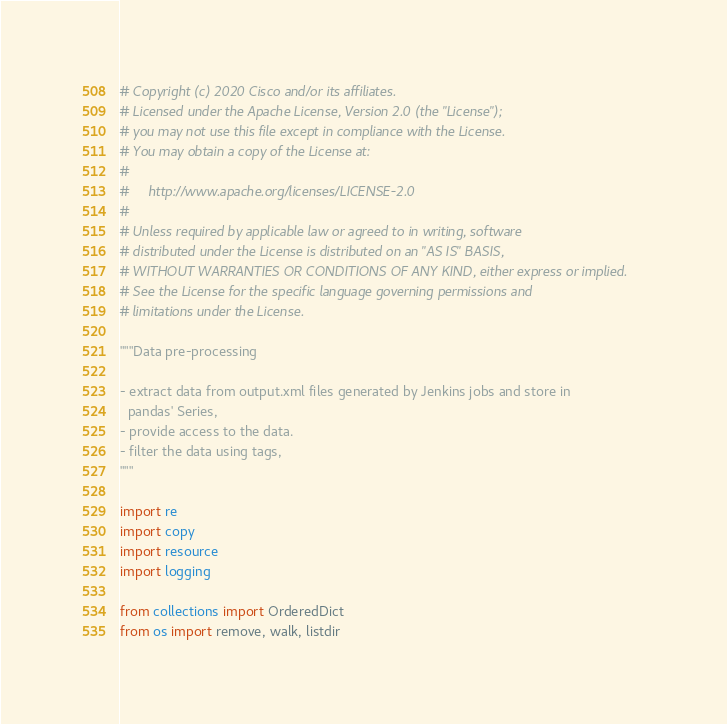<code> <loc_0><loc_0><loc_500><loc_500><_Python_># Copyright (c) 2020 Cisco and/or its affiliates.
# Licensed under the Apache License, Version 2.0 (the "License");
# you may not use this file except in compliance with the License.
# You may obtain a copy of the License at:
#
#     http://www.apache.org/licenses/LICENSE-2.0
#
# Unless required by applicable law or agreed to in writing, software
# distributed under the License is distributed on an "AS IS" BASIS,
# WITHOUT WARRANTIES OR CONDITIONS OF ANY KIND, either express or implied.
# See the License for the specific language governing permissions and
# limitations under the License.

"""Data pre-processing

- extract data from output.xml files generated by Jenkins jobs and store in
  pandas' Series,
- provide access to the data.
- filter the data using tags,
"""

import re
import copy
import resource
import logging

from collections import OrderedDict
from os import remove, walk, listdir</code> 